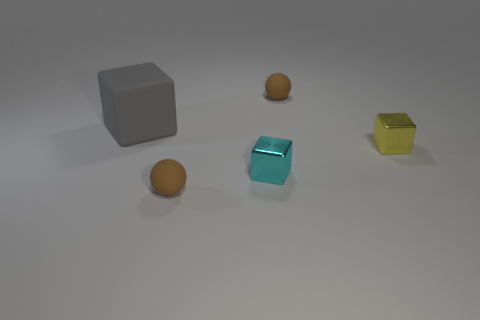Subtract all gray blocks. Subtract all gray cylinders. How many blocks are left? 2 Add 5 small matte things. How many objects exist? 10 Subtract all blocks. How many objects are left? 2 Add 4 yellow objects. How many yellow objects are left? 5 Add 2 cyan things. How many cyan things exist? 3 Subtract 2 brown spheres. How many objects are left? 3 Subtract all small things. Subtract all gray blocks. How many objects are left? 0 